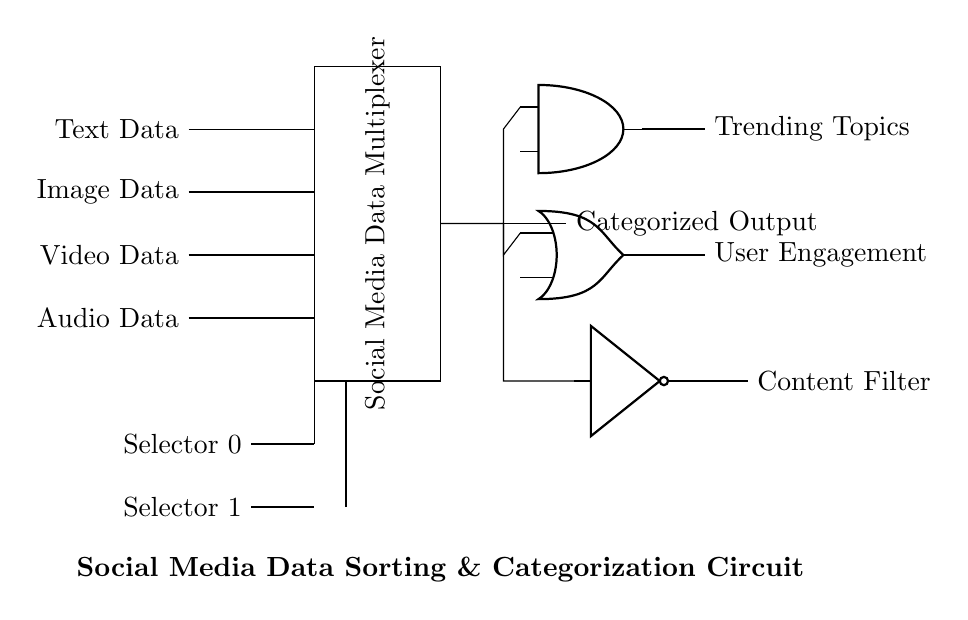What types of data inputs does the multiplexer receive? The circuit diagram shows four types of data inputs: Text Data, Image Data, Video Data, and Audio Data. These labels are clearly indicated on the left side of the multiplexer rectangle.
Answer: Text Data, Image Data, Video Data, Audio Data What is the main function of the multiplexer in this circuit? The multiplexer is designed to select one type of social media data input and route it to the categorized output. This is indicated by its labeled role in the circuit diagram.
Answer: Data selection How many selector lines are present in the circuit? The circuit diagram shows two selector lines labeled Selector 0 and Selector 1, which are used to control the output selection of the multiplexer.
Answer: Two What types of logic gates are implemented in the circuit? The circuit incorporates three types of logic gates: an AND gate, an OR gate, and a NOT gate. Each gate is physically represented in specific locations in the diagram, each with distinct functions.
Answer: AND, OR, NOT What output does the AND gate provide? The AND gate in the circuit provides the output labeled Trending Topics, which means it reflects data regarding the topics that are currently trending based on input data.
Answer: Trending Topics Explain how User Engagement is derived from the circuit logic. The User Engagement output is derived from the OR gate, which signifies that it accumulates input signals from the various data types. The OR gate allows for any high signal from its inputs to result in a high output. Thus, any form of user engagement data will come through this gate.
Answer: Through the OR gate What is the purpose of the Content Filter logic? The Content Filter is generated by the NOT gate, which inverts the signal it receives from the input data. Its purpose is to categorize content by filtering out unwanted data or categories based on specific parameters. This ensures that only the desired content type is processed and output.
Answer: To filter content 